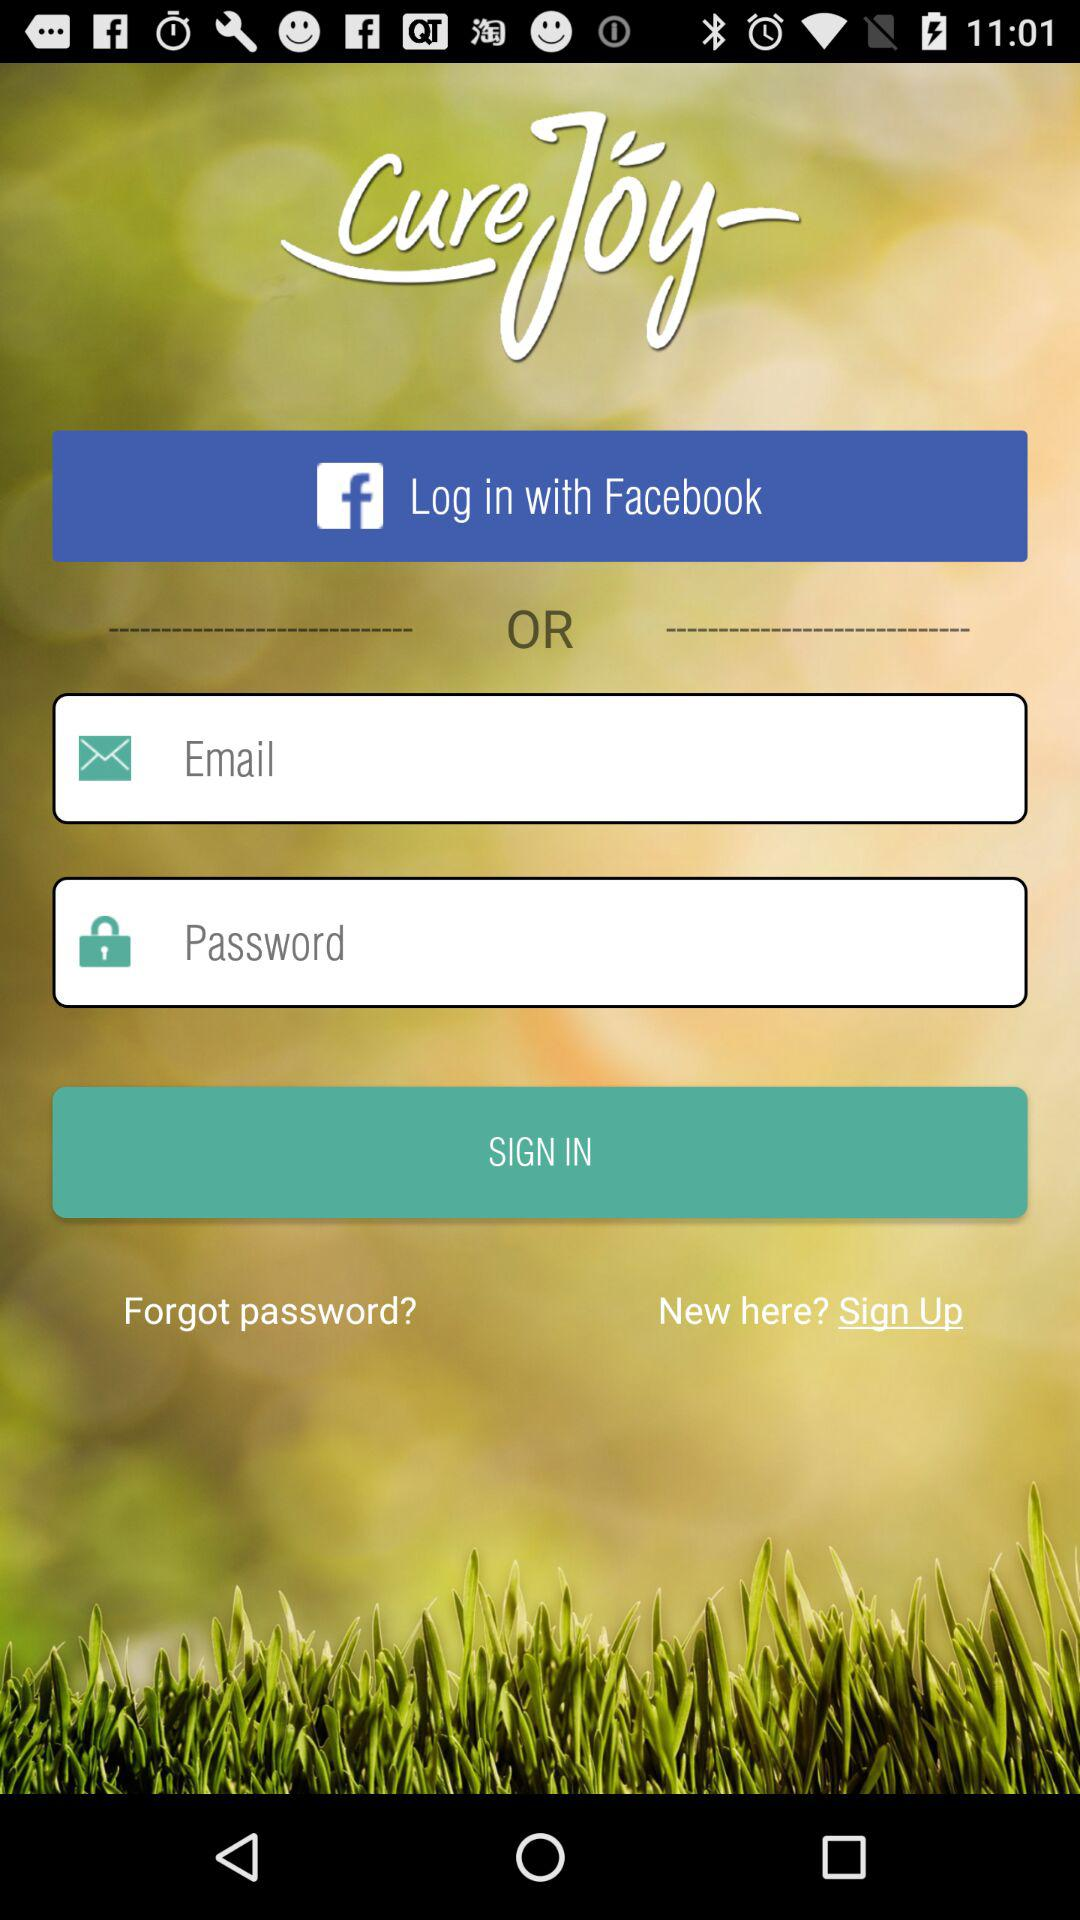Through what app can we login? You can login through "Facebook". 